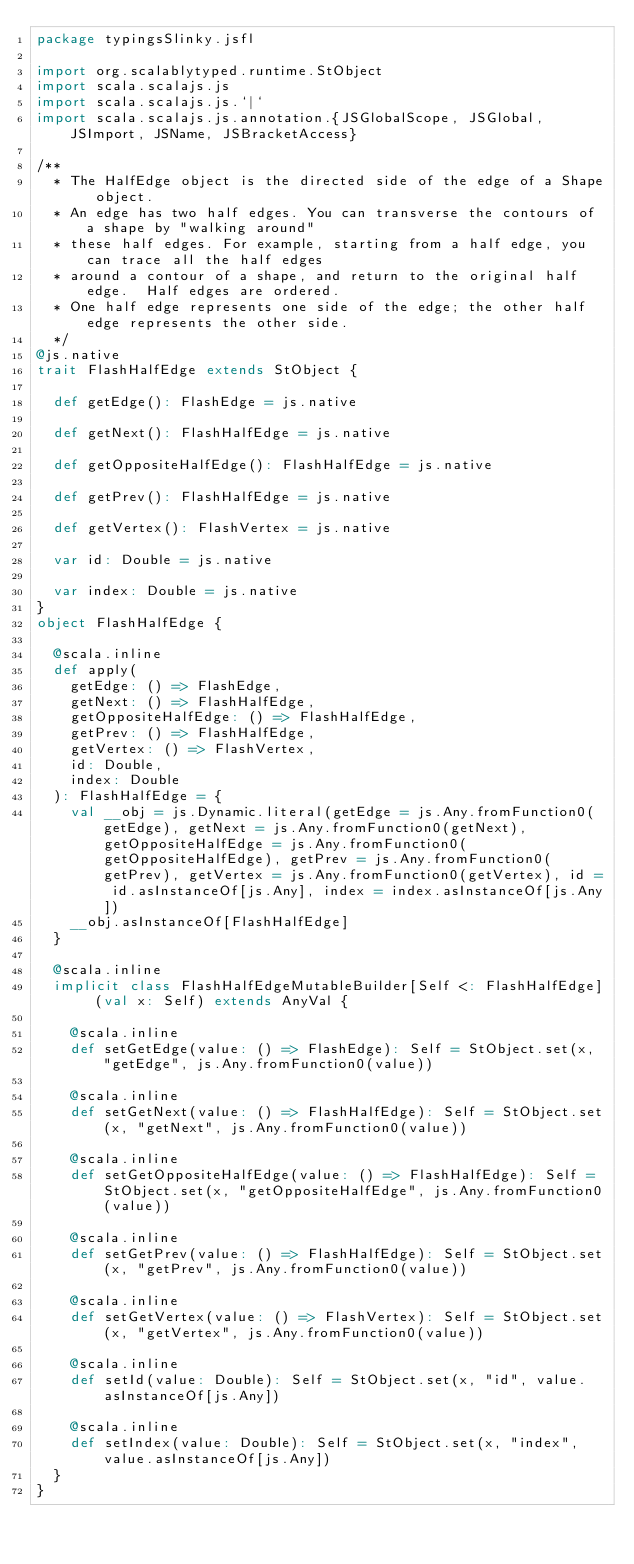<code> <loc_0><loc_0><loc_500><loc_500><_Scala_>package typingsSlinky.jsfl

import org.scalablytyped.runtime.StObject
import scala.scalajs.js
import scala.scalajs.js.`|`
import scala.scalajs.js.annotation.{JSGlobalScope, JSGlobal, JSImport, JSName, JSBracketAccess}

/**
  * The HalfEdge object is the directed side of the edge of a Shape object.
  * An edge has two half edges. You can transverse the contours of a shape by "walking around"
  * these half edges. For example, starting from a half edge, you can trace all the half edges
  * around a contour of a shape, and return to the original half edge.  Half edges are ordered.
  * One half edge represents one side of the edge; the other half edge represents the other side.
  */
@js.native
trait FlashHalfEdge extends StObject {
  
  def getEdge(): FlashEdge = js.native
  
  def getNext(): FlashHalfEdge = js.native
  
  def getOppositeHalfEdge(): FlashHalfEdge = js.native
  
  def getPrev(): FlashHalfEdge = js.native
  
  def getVertex(): FlashVertex = js.native
  
  var id: Double = js.native
  
  var index: Double = js.native
}
object FlashHalfEdge {
  
  @scala.inline
  def apply(
    getEdge: () => FlashEdge,
    getNext: () => FlashHalfEdge,
    getOppositeHalfEdge: () => FlashHalfEdge,
    getPrev: () => FlashHalfEdge,
    getVertex: () => FlashVertex,
    id: Double,
    index: Double
  ): FlashHalfEdge = {
    val __obj = js.Dynamic.literal(getEdge = js.Any.fromFunction0(getEdge), getNext = js.Any.fromFunction0(getNext), getOppositeHalfEdge = js.Any.fromFunction0(getOppositeHalfEdge), getPrev = js.Any.fromFunction0(getPrev), getVertex = js.Any.fromFunction0(getVertex), id = id.asInstanceOf[js.Any], index = index.asInstanceOf[js.Any])
    __obj.asInstanceOf[FlashHalfEdge]
  }
  
  @scala.inline
  implicit class FlashHalfEdgeMutableBuilder[Self <: FlashHalfEdge] (val x: Self) extends AnyVal {
    
    @scala.inline
    def setGetEdge(value: () => FlashEdge): Self = StObject.set(x, "getEdge", js.Any.fromFunction0(value))
    
    @scala.inline
    def setGetNext(value: () => FlashHalfEdge): Self = StObject.set(x, "getNext", js.Any.fromFunction0(value))
    
    @scala.inline
    def setGetOppositeHalfEdge(value: () => FlashHalfEdge): Self = StObject.set(x, "getOppositeHalfEdge", js.Any.fromFunction0(value))
    
    @scala.inline
    def setGetPrev(value: () => FlashHalfEdge): Self = StObject.set(x, "getPrev", js.Any.fromFunction0(value))
    
    @scala.inline
    def setGetVertex(value: () => FlashVertex): Self = StObject.set(x, "getVertex", js.Any.fromFunction0(value))
    
    @scala.inline
    def setId(value: Double): Self = StObject.set(x, "id", value.asInstanceOf[js.Any])
    
    @scala.inline
    def setIndex(value: Double): Self = StObject.set(x, "index", value.asInstanceOf[js.Any])
  }
}
</code> 